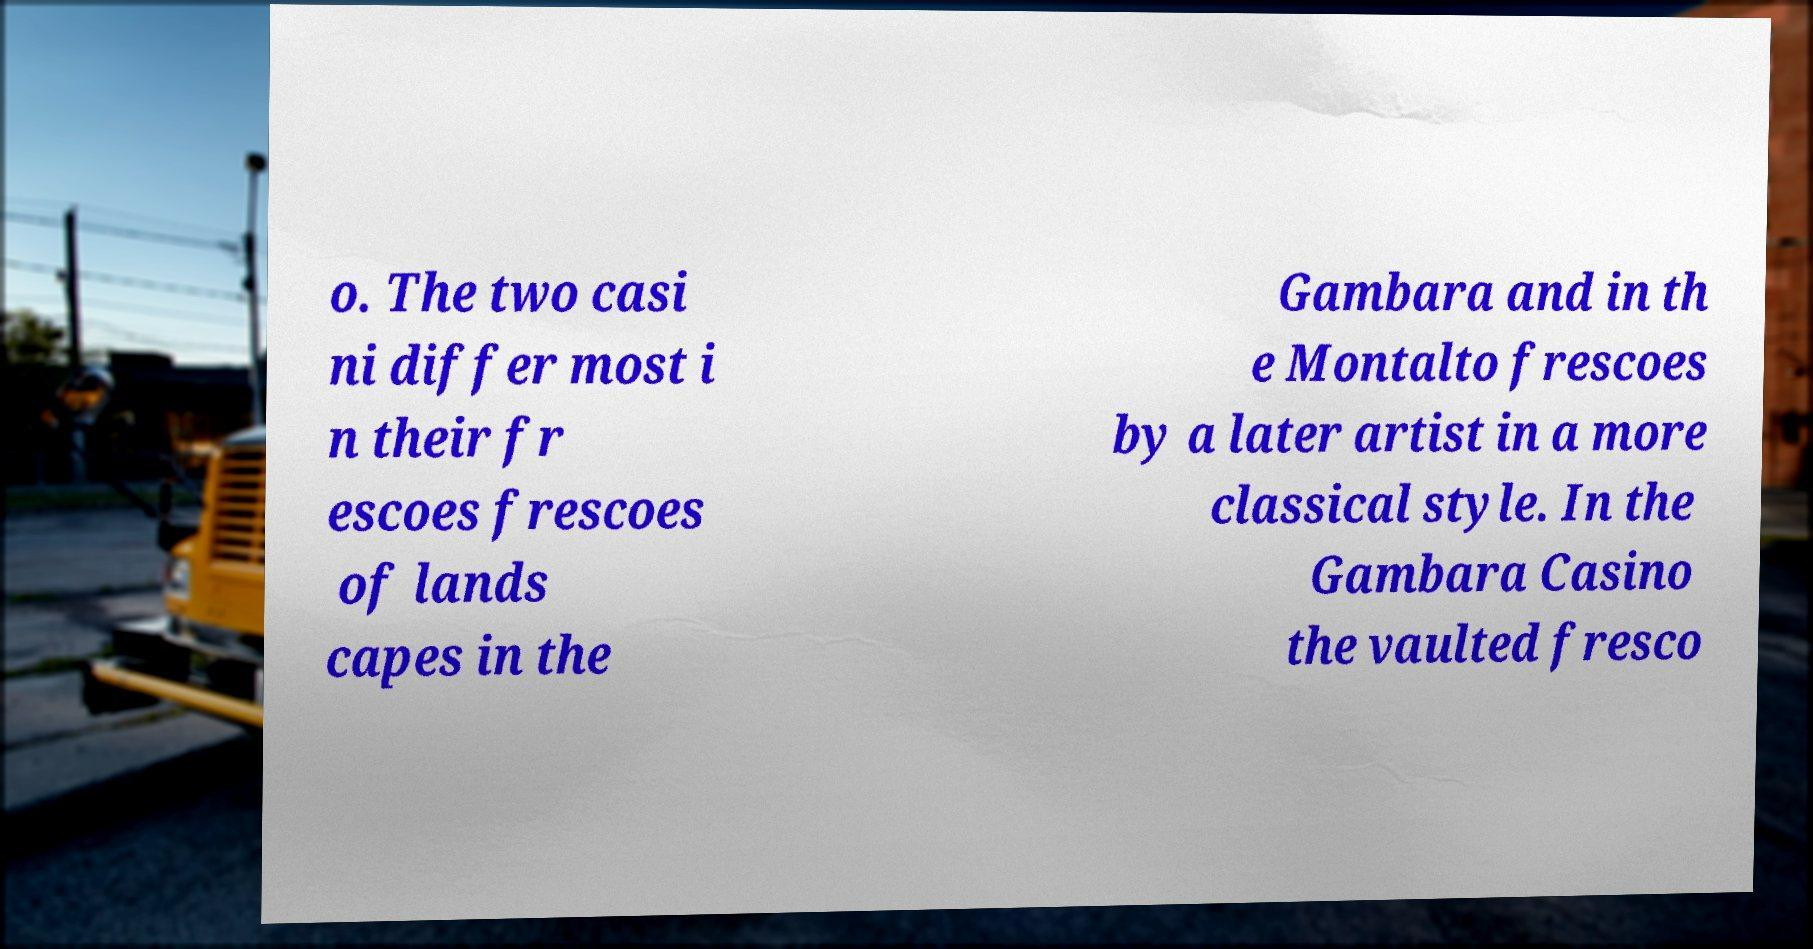For documentation purposes, I need the text within this image transcribed. Could you provide that? o. The two casi ni differ most i n their fr escoes frescoes of lands capes in the Gambara and in th e Montalto frescoes by a later artist in a more classical style. In the Gambara Casino the vaulted fresco 